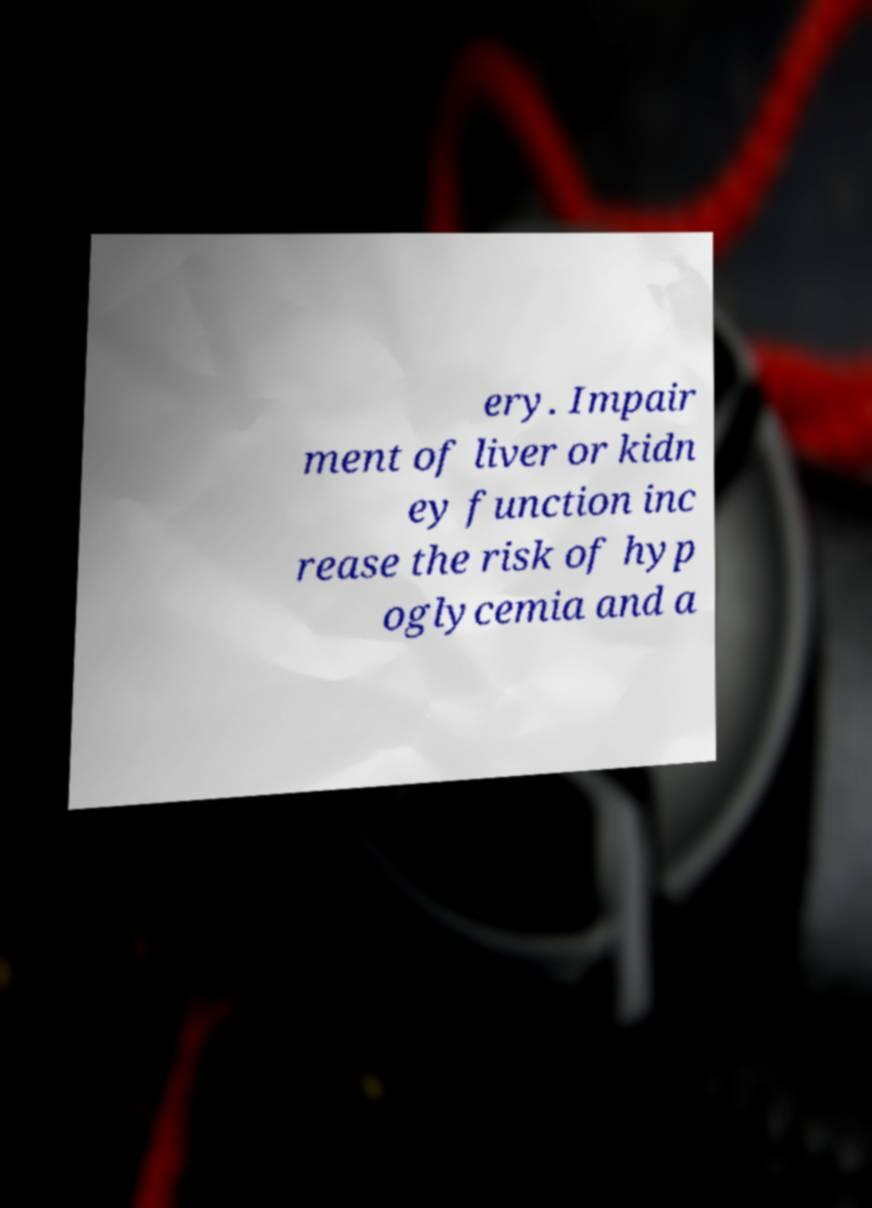Could you assist in decoding the text presented in this image and type it out clearly? ery. Impair ment of liver or kidn ey function inc rease the risk of hyp oglycemia and a 